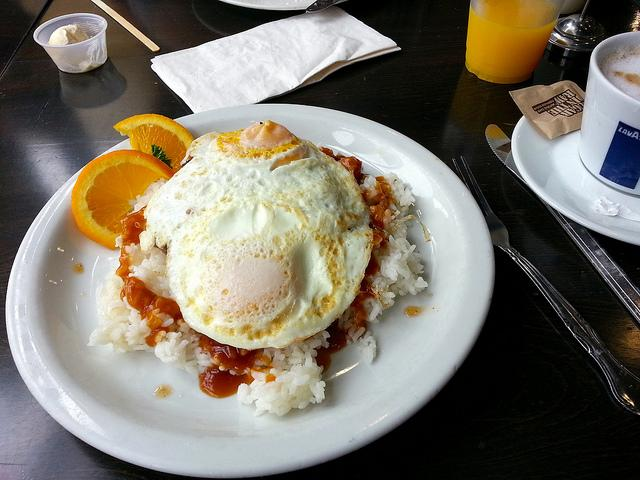What is in the tall glass on the right hand side?

Choices:
A) root beer
B) orange juice
C) water
D) tomato juice orange juice 